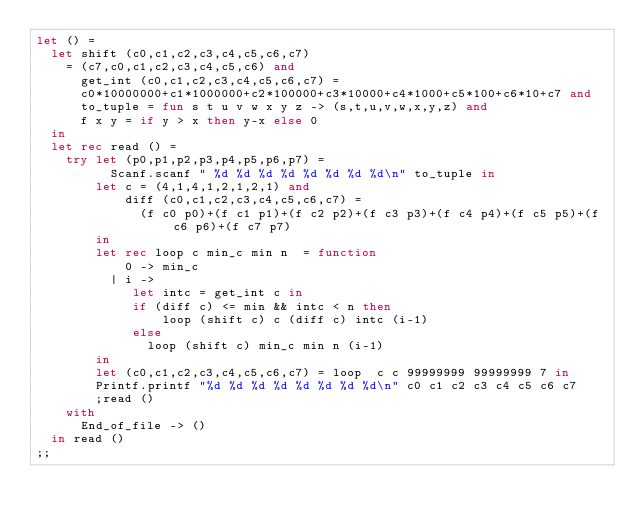Convert code to text. <code><loc_0><loc_0><loc_500><loc_500><_OCaml_>let () =
  let shift (c0,c1,c2,c3,c4,c5,c6,c7)
    = (c7,c0,c1,c2,c3,c4,c5,c6) and
      get_int (c0,c1,c2,c3,c4,c5,c6,c7) =
      c0*10000000+c1*1000000+c2*100000+c3*10000+c4*1000+c5*100+c6*10+c7 and
      to_tuple = fun s t u v w x y z -> (s,t,u,v,w,x,y,z) and
      f x y = if y > x then y-x else 0
  in
  let rec read () =
    try let (p0,p1,p2,p3,p4,p5,p6,p7) =
          Scanf.scanf " %d %d %d %d %d %d %d %d\n" to_tuple in
        let c = (4,1,4,1,2,1,2,1) and
            diff (c0,c1,c2,c3,c4,c5,c6,c7) =
              (f c0 p0)+(f c1 p1)+(f c2 p2)+(f c3 p3)+(f c4 p4)+(f c5 p5)+(f c6 p6)+(f c7 p7)
        in
        let rec loop c min_c min n  = function
            0 -> min_c
          | i ->
             let intc = get_int c in
             if (diff c) <= min && intc < n then
                 loop (shift c) c (diff c) intc (i-1)
             else
               loop (shift c) min_c min n (i-1)
        in
        let (c0,c1,c2,c3,c4,c5,c6,c7) = loop  c c 99999999 99999999 7 in
        Printf.printf "%d %d %d %d %d %d %d %d\n" c0 c1 c2 c3 c4 c5 c6 c7
        ;read ()
    with
      End_of_file -> ()
  in read ()
;;</code> 